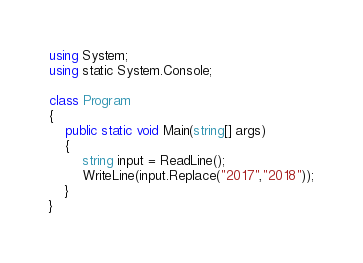<code> <loc_0><loc_0><loc_500><loc_500><_C#_>using System;
using static System.Console;

class Program
{
    public static void Main(string[] args)
    {
        string input = ReadLine();
        WriteLine(input.Replace("2017","2018"));
    }
}</code> 